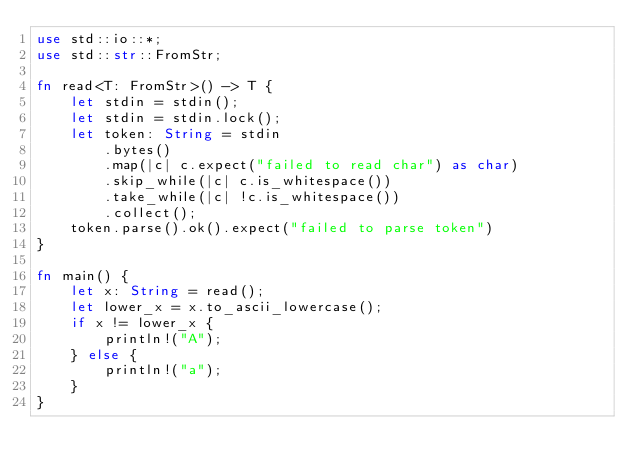<code> <loc_0><loc_0><loc_500><loc_500><_Rust_>use std::io::*;
use std::str::FromStr;

fn read<T: FromStr>() -> T {
    let stdin = stdin();
    let stdin = stdin.lock();
    let token: String = stdin
        .bytes()
        .map(|c| c.expect("failed to read char") as char)
        .skip_while(|c| c.is_whitespace())
        .take_while(|c| !c.is_whitespace())
        .collect();
    token.parse().ok().expect("failed to parse token")
}

fn main() {
    let x: String = read();
    let lower_x = x.to_ascii_lowercase();
    if x != lower_x {
        println!("A");
    } else {
        println!("a");
    }
}
</code> 